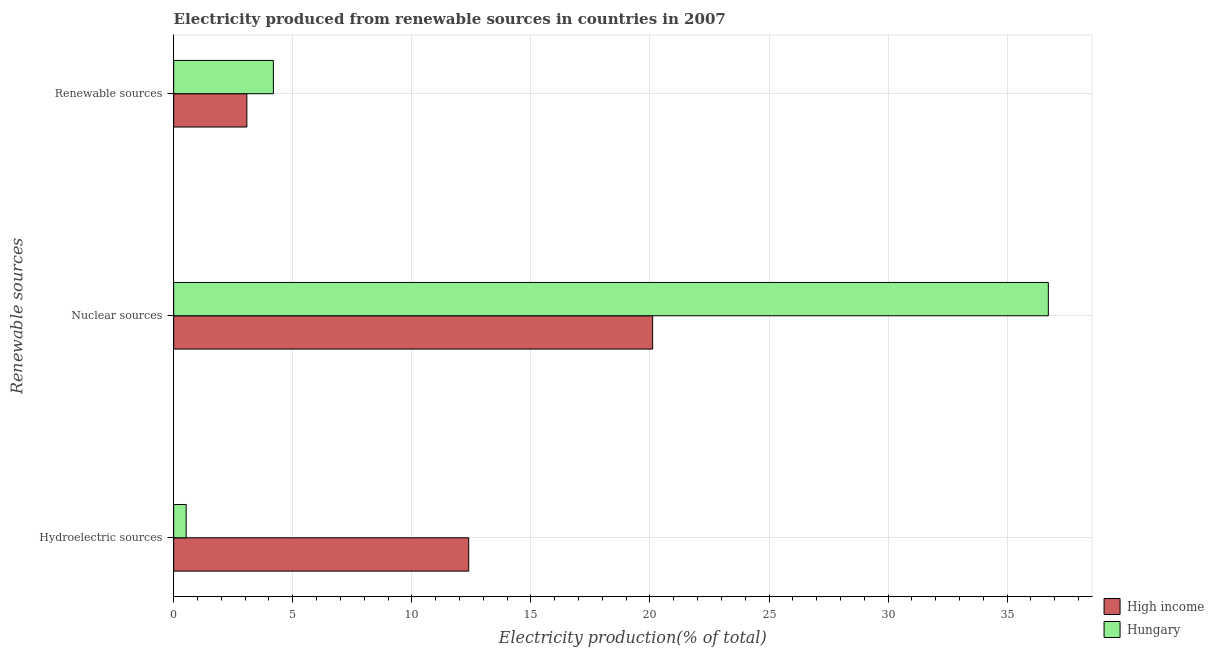How many groups of bars are there?
Keep it short and to the point. 3. Are the number of bars per tick equal to the number of legend labels?
Provide a short and direct response. Yes. Are the number of bars on each tick of the Y-axis equal?
Your response must be concise. Yes. How many bars are there on the 3rd tick from the top?
Your answer should be very brief. 2. How many bars are there on the 2nd tick from the bottom?
Make the answer very short. 2. What is the label of the 2nd group of bars from the top?
Keep it short and to the point. Nuclear sources. What is the percentage of electricity produced by hydroelectric sources in High income?
Provide a short and direct response. 12.39. Across all countries, what is the maximum percentage of electricity produced by renewable sources?
Give a very brief answer. 4.19. Across all countries, what is the minimum percentage of electricity produced by renewable sources?
Your answer should be very brief. 3.07. In which country was the percentage of electricity produced by renewable sources maximum?
Offer a very short reply. Hungary. What is the total percentage of electricity produced by renewable sources in the graph?
Offer a terse response. 7.26. What is the difference between the percentage of electricity produced by hydroelectric sources in High income and that in Hungary?
Offer a terse response. 11.86. What is the difference between the percentage of electricity produced by hydroelectric sources in Hungary and the percentage of electricity produced by nuclear sources in High income?
Offer a terse response. -19.59. What is the average percentage of electricity produced by hydroelectric sources per country?
Your response must be concise. 6.46. What is the difference between the percentage of electricity produced by hydroelectric sources and percentage of electricity produced by nuclear sources in Hungary?
Offer a terse response. -36.2. In how many countries, is the percentage of electricity produced by renewable sources greater than 6 %?
Offer a terse response. 0. What is the ratio of the percentage of electricity produced by renewable sources in High income to that in Hungary?
Keep it short and to the point. 0.73. Is the percentage of electricity produced by nuclear sources in High income less than that in Hungary?
Your response must be concise. Yes. Is the difference between the percentage of electricity produced by nuclear sources in High income and Hungary greater than the difference between the percentage of electricity produced by renewable sources in High income and Hungary?
Keep it short and to the point. No. What is the difference between the highest and the second highest percentage of electricity produced by hydroelectric sources?
Offer a terse response. 11.86. What is the difference between the highest and the lowest percentage of electricity produced by hydroelectric sources?
Ensure brevity in your answer.  11.86. In how many countries, is the percentage of electricity produced by renewable sources greater than the average percentage of electricity produced by renewable sources taken over all countries?
Offer a terse response. 1. How many bars are there?
Ensure brevity in your answer.  6. Are all the bars in the graph horizontal?
Your answer should be very brief. Yes. How many countries are there in the graph?
Make the answer very short. 2. What is the difference between two consecutive major ticks on the X-axis?
Your answer should be compact. 5. Does the graph contain any zero values?
Offer a very short reply. No. Does the graph contain grids?
Make the answer very short. Yes. How many legend labels are there?
Offer a very short reply. 2. What is the title of the graph?
Provide a short and direct response. Electricity produced from renewable sources in countries in 2007. Does "South Sudan" appear as one of the legend labels in the graph?
Provide a short and direct response. No. What is the label or title of the Y-axis?
Keep it short and to the point. Renewable sources. What is the Electricity production(% of total) in High income in Hydroelectric sources?
Provide a succinct answer. 12.39. What is the Electricity production(% of total) of Hungary in Hydroelectric sources?
Your answer should be compact. 0.53. What is the Electricity production(% of total) of High income in Nuclear sources?
Offer a terse response. 20.11. What is the Electricity production(% of total) of Hungary in Nuclear sources?
Make the answer very short. 36.73. What is the Electricity production(% of total) of High income in Renewable sources?
Your response must be concise. 3.07. What is the Electricity production(% of total) of Hungary in Renewable sources?
Your answer should be very brief. 4.19. Across all Renewable sources, what is the maximum Electricity production(% of total) in High income?
Ensure brevity in your answer.  20.11. Across all Renewable sources, what is the maximum Electricity production(% of total) in Hungary?
Give a very brief answer. 36.73. Across all Renewable sources, what is the minimum Electricity production(% of total) in High income?
Provide a short and direct response. 3.07. Across all Renewable sources, what is the minimum Electricity production(% of total) of Hungary?
Provide a short and direct response. 0.53. What is the total Electricity production(% of total) of High income in the graph?
Offer a very short reply. 35.58. What is the total Electricity production(% of total) in Hungary in the graph?
Your answer should be very brief. 41.44. What is the difference between the Electricity production(% of total) of High income in Hydroelectric sources and that in Nuclear sources?
Offer a terse response. -7.72. What is the difference between the Electricity production(% of total) of Hungary in Hydroelectric sources and that in Nuclear sources?
Provide a short and direct response. -36.2. What is the difference between the Electricity production(% of total) of High income in Hydroelectric sources and that in Renewable sources?
Give a very brief answer. 9.32. What is the difference between the Electricity production(% of total) in Hungary in Hydroelectric sources and that in Renewable sources?
Your answer should be very brief. -3.66. What is the difference between the Electricity production(% of total) in High income in Nuclear sources and that in Renewable sources?
Ensure brevity in your answer.  17.04. What is the difference between the Electricity production(% of total) in Hungary in Nuclear sources and that in Renewable sources?
Your answer should be very brief. 32.54. What is the difference between the Electricity production(% of total) in High income in Hydroelectric sources and the Electricity production(% of total) in Hungary in Nuclear sources?
Give a very brief answer. -24.34. What is the difference between the Electricity production(% of total) of High income in Hydroelectric sources and the Electricity production(% of total) of Hungary in Renewable sources?
Ensure brevity in your answer.  8.2. What is the difference between the Electricity production(% of total) in High income in Nuclear sources and the Electricity production(% of total) in Hungary in Renewable sources?
Provide a succinct answer. 15.93. What is the average Electricity production(% of total) in High income per Renewable sources?
Keep it short and to the point. 11.86. What is the average Electricity production(% of total) in Hungary per Renewable sources?
Offer a very short reply. 13.81. What is the difference between the Electricity production(% of total) in High income and Electricity production(% of total) in Hungary in Hydroelectric sources?
Provide a succinct answer. 11.86. What is the difference between the Electricity production(% of total) of High income and Electricity production(% of total) of Hungary in Nuclear sources?
Provide a succinct answer. -16.62. What is the difference between the Electricity production(% of total) of High income and Electricity production(% of total) of Hungary in Renewable sources?
Provide a short and direct response. -1.11. What is the ratio of the Electricity production(% of total) in High income in Hydroelectric sources to that in Nuclear sources?
Your answer should be compact. 0.62. What is the ratio of the Electricity production(% of total) of Hungary in Hydroelectric sources to that in Nuclear sources?
Offer a terse response. 0.01. What is the ratio of the Electricity production(% of total) in High income in Hydroelectric sources to that in Renewable sources?
Offer a very short reply. 4.03. What is the ratio of the Electricity production(% of total) of Hungary in Hydroelectric sources to that in Renewable sources?
Provide a short and direct response. 0.13. What is the ratio of the Electricity production(% of total) of High income in Nuclear sources to that in Renewable sources?
Provide a short and direct response. 6.55. What is the ratio of the Electricity production(% of total) in Hungary in Nuclear sources to that in Renewable sources?
Keep it short and to the point. 8.77. What is the difference between the highest and the second highest Electricity production(% of total) in High income?
Your response must be concise. 7.72. What is the difference between the highest and the second highest Electricity production(% of total) of Hungary?
Make the answer very short. 32.54. What is the difference between the highest and the lowest Electricity production(% of total) in High income?
Offer a terse response. 17.04. What is the difference between the highest and the lowest Electricity production(% of total) of Hungary?
Offer a very short reply. 36.2. 